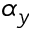<formula> <loc_0><loc_0><loc_500><loc_500>\alpha _ { y }</formula> 